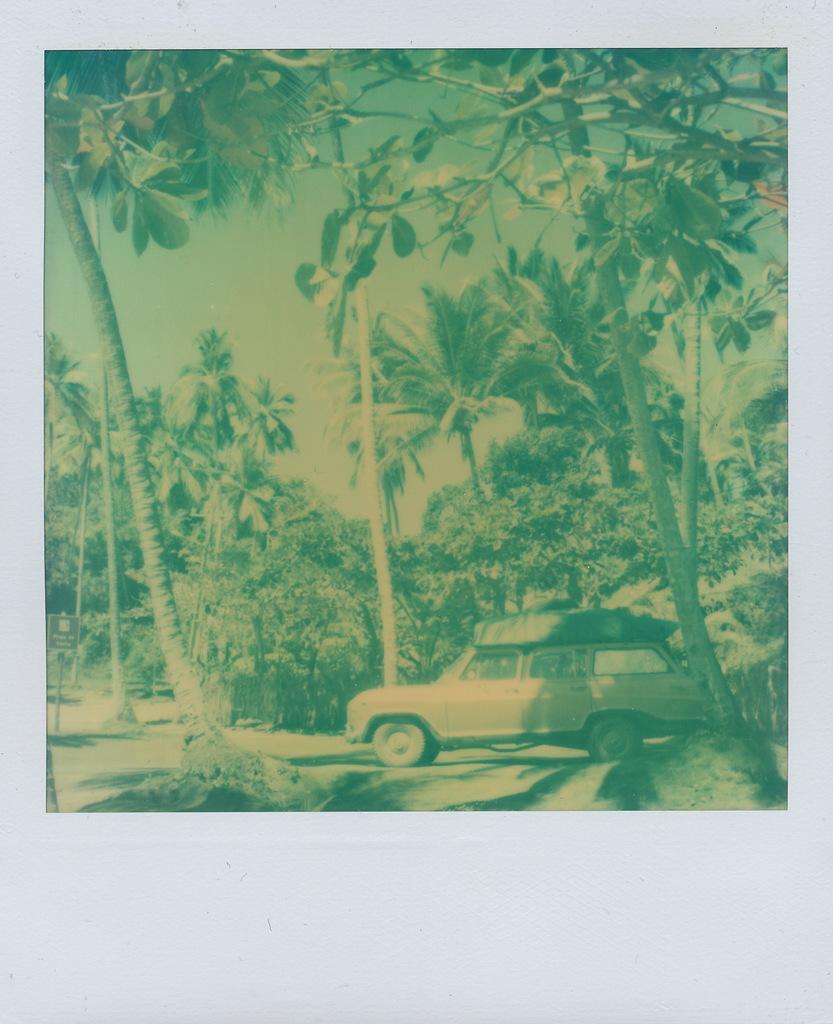Could you give a brief overview of what you see in this image? In this picture we can see the photo on the wall. In that photo we can see trees, plants, grass, sign board, car and sky. 